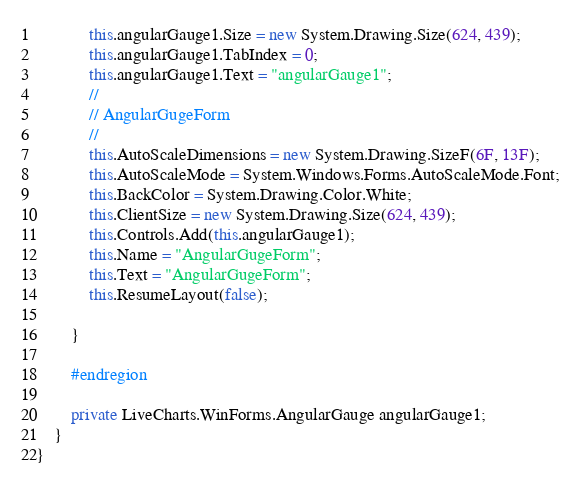Convert code to text. <code><loc_0><loc_0><loc_500><loc_500><_C#_>            this.angularGauge1.Size = new System.Drawing.Size(624, 439);
            this.angularGauge1.TabIndex = 0;
            this.angularGauge1.Text = "angularGauge1";
            // 
            // AngularGugeForm
            // 
            this.AutoScaleDimensions = new System.Drawing.SizeF(6F, 13F);
            this.AutoScaleMode = System.Windows.Forms.AutoScaleMode.Font;
            this.BackColor = System.Drawing.Color.White;
            this.ClientSize = new System.Drawing.Size(624, 439);
            this.Controls.Add(this.angularGauge1);
            this.Name = "AngularGugeForm";
            this.Text = "AngularGugeForm";
            this.ResumeLayout(false);

        }

        #endregion

        private LiveCharts.WinForms.AngularGauge angularGauge1;
    }
}</code> 